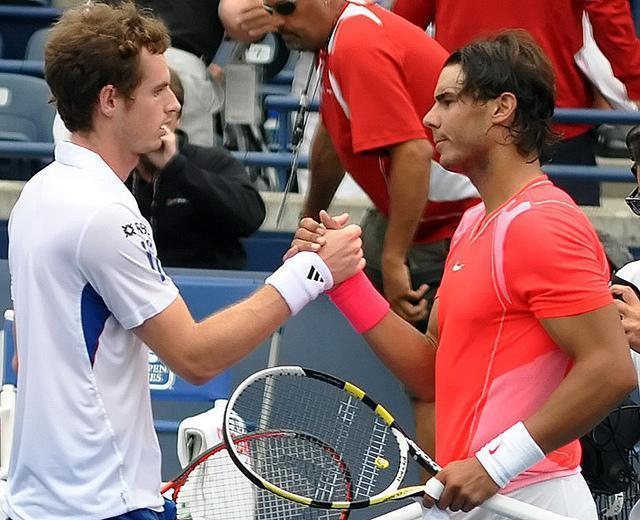What did the two men shaking hands just do?
Choose the correct response, then elucidate: 'Answer: answer
Rationale: rationale.'
Options: Had lunch, played baseball, went bowling, played tennis. Answer: played tennis.
Rationale: They just finished a game. 